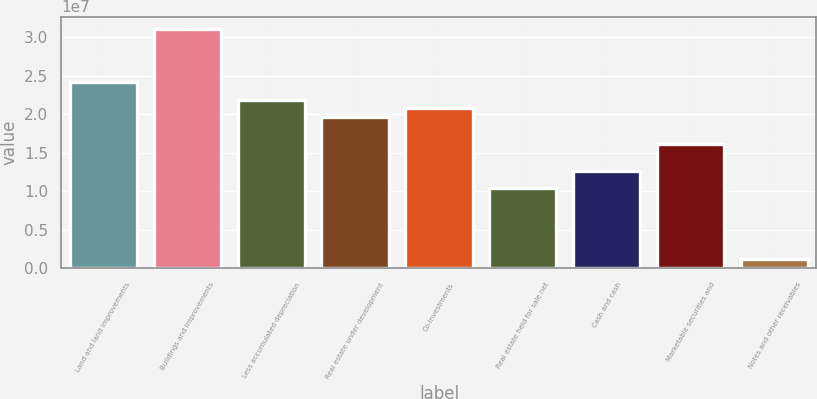Convert chart. <chart><loc_0><loc_0><loc_500><loc_500><bar_chart><fcel>Land and land improvements<fcel>Buildings and improvements<fcel>Less accumulated depreciation<fcel>Real estate under development<fcel>Co-investments<fcel>Real estate held for sale net<fcel>Cash and cash<fcel>Marketable securities and<fcel>Notes and other receivables<nl><fcel>2.41806e+07<fcel>3.10826e+07<fcel>2.18799e+07<fcel>1.95792e+07<fcel>2.07295e+07<fcel>1.03764e+07<fcel>1.26771e+07<fcel>1.61281e+07<fcel>1.1736e+06<nl></chart> 